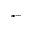<formula> <loc_0><loc_0><loc_500><loc_500>^ { * - }</formula> 